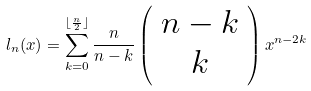Convert formula to latex. <formula><loc_0><loc_0><loc_500><loc_500>l _ { n } ( x ) = \sum _ { k = 0 } ^ { \lfloor \frac { n } { 2 } \rfloor } \frac { n } { n - k } \left ( \begin{array} { c } n - k \\ k \end{array} \right ) x ^ { n - 2 k }</formula> 